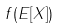Convert formula to latex. <formula><loc_0><loc_0><loc_500><loc_500>f ( E [ X ] )</formula> 